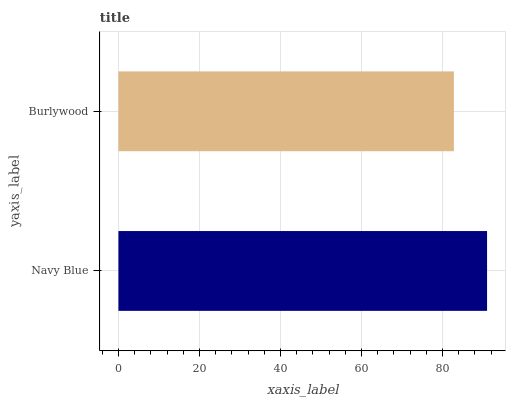Is Burlywood the minimum?
Answer yes or no. Yes. Is Navy Blue the maximum?
Answer yes or no. Yes. Is Burlywood the maximum?
Answer yes or no. No. Is Navy Blue greater than Burlywood?
Answer yes or no. Yes. Is Burlywood less than Navy Blue?
Answer yes or no. Yes. Is Burlywood greater than Navy Blue?
Answer yes or no. No. Is Navy Blue less than Burlywood?
Answer yes or no. No. Is Navy Blue the high median?
Answer yes or no. Yes. Is Burlywood the low median?
Answer yes or no. Yes. Is Burlywood the high median?
Answer yes or no. No. Is Navy Blue the low median?
Answer yes or no. No. 